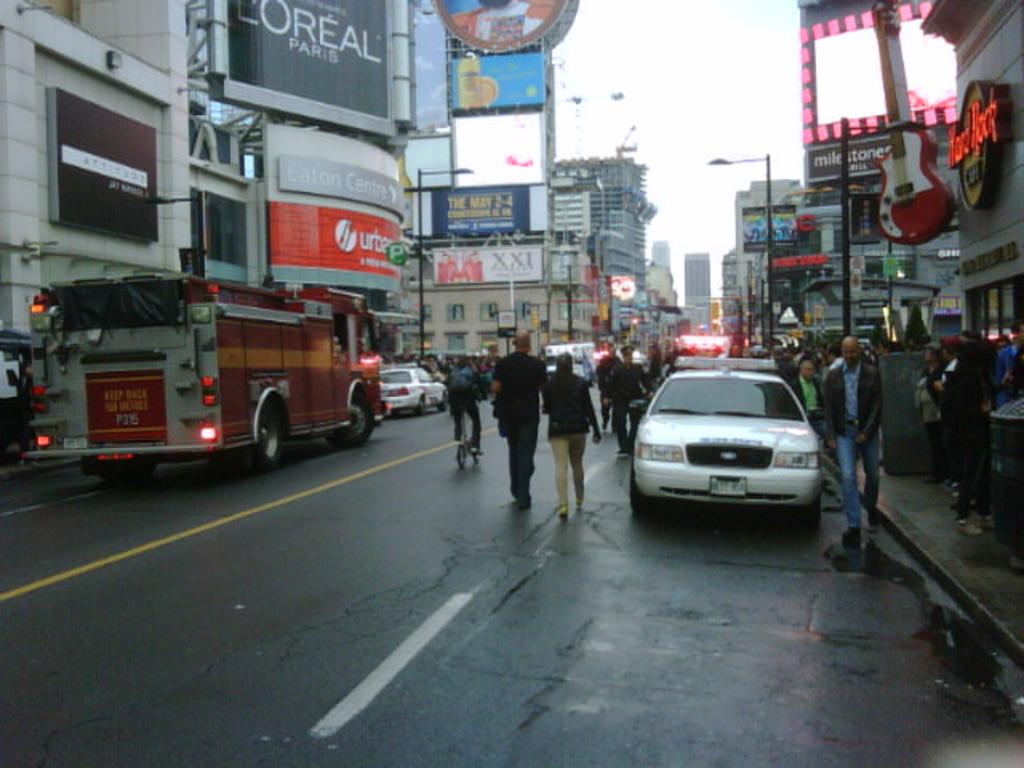What is the main feature of the image? There is a road in the image. What can be seen alongside the road? Vehicles are parked on either side of the road. What are people doing in the image? People are walking on the road and on the footpath. What type of establishments are present in the image? There are shops on both the left and right sides of the image. What type of tail can be seen on the carriage in the image? There is no carriage or tail present in the image. 